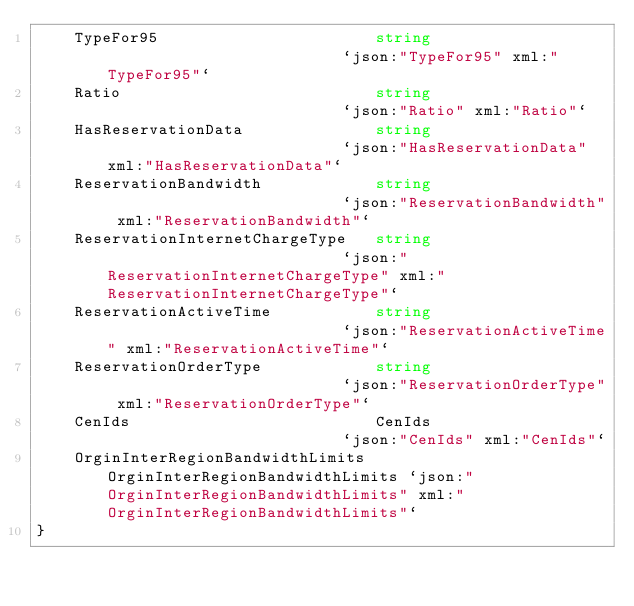Convert code to text. <code><loc_0><loc_0><loc_500><loc_500><_Go_>	TypeFor95                       string                          `json:"TypeFor95" xml:"TypeFor95"`
	Ratio                           string                          `json:"Ratio" xml:"Ratio"`
	HasReservationData              string                          `json:"HasReservationData" xml:"HasReservationData"`
	ReservationBandwidth            string                          `json:"ReservationBandwidth" xml:"ReservationBandwidth"`
	ReservationInternetChargeType   string                          `json:"ReservationInternetChargeType" xml:"ReservationInternetChargeType"`
	ReservationActiveTime           string                          `json:"ReservationActiveTime" xml:"ReservationActiveTime"`
	ReservationOrderType            string                          `json:"ReservationOrderType" xml:"ReservationOrderType"`
	CenIds                          CenIds                          `json:"CenIds" xml:"CenIds"`
	OrginInterRegionBandwidthLimits OrginInterRegionBandwidthLimits `json:"OrginInterRegionBandwidthLimits" xml:"OrginInterRegionBandwidthLimits"`
}
</code> 